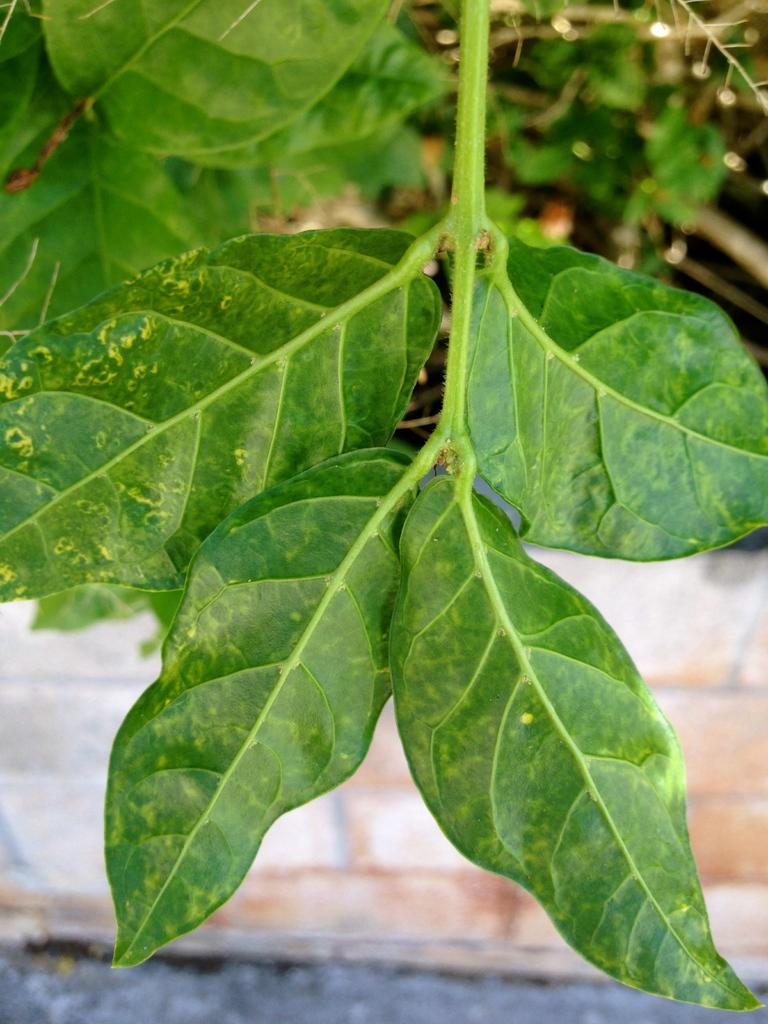In one or two sentences, can you explain what this image depicts? In this image, green leaves with stem. Background there is a wall and road. Top of the image, we can see leaves and stems. 